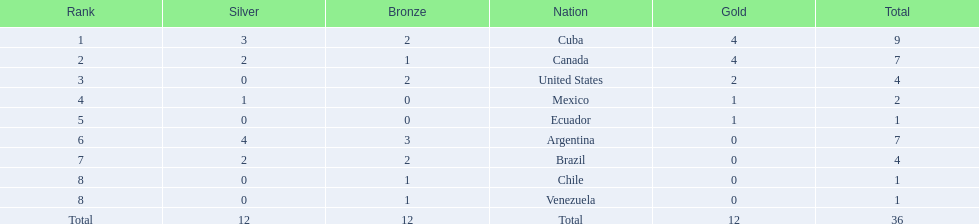Which nations competed in the 2011 pan american games? Cuba, Canada, United States, Mexico, Ecuador, Argentina, Brazil, Chile, Venezuela. Of these nations which ones won gold? Cuba, Canada, United States, Mexico, Ecuador. Which nation of the ones that won gold did not win silver? United States. 